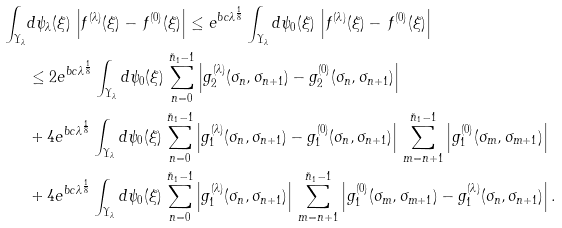Convert formula to latex. <formula><loc_0><loc_0><loc_500><loc_500>\int _ { \Upsilon _ { \lambda } } & d \psi _ { \lambda } ( \xi ) \, \left | f ^ { ( \lambda ) } ( \xi ) - \, f ^ { ( 0 ) } ( \xi ) \right | \leq e ^ { b c \lambda ^ { \frac { 1 } { 8 } } } \int _ { \Upsilon _ { \lambda } } d \psi _ { 0 } ( \xi ) \, \left | f ^ { ( \lambda ) } ( \xi ) - \, f ^ { ( 0 ) } ( \xi ) \right | \\ & \leq 2 e ^ { b c \lambda ^ { \frac { 1 } { 8 } } } \int _ { \Upsilon _ { \lambda } } d \psi _ { 0 } ( \xi ) \, \sum _ { n = 0 } ^ { \tilde { n } _ { 1 } - 1 } \left | g _ { 2 } ^ { ( \lambda ) } ( \sigma _ { n } , \sigma _ { n + 1 } ) - g _ { 2 } ^ { ( 0 ) } ( \sigma _ { n } , \sigma _ { n + 1 } ) \right | \\ & + 4 e ^ { b c \lambda ^ { \frac { 1 } { 8 } } } \int _ { \Upsilon _ { \lambda } } d \psi _ { 0 } ( \xi ) \, \sum _ { n = 0 } ^ { \tilde { n } _ { 1 } - 1 } \left | g _ { 1 } ^ { ( \lambda ) } ( \sigma _ { n } , \sigma _ { n + 1 } ) - g _ { 1 } ^ { ( 0 ) } ( \sigma _ { n } , \sigma _ { n + 1 } ) \right | \, \sum _ { m = n + 1 } ^ { \tilde { n } _ { 1 } - 1 } \left | g _ { 1 } ^ { ( 0 ) } ( \sigma _ { m } , \sigma _ { m + 1 } ) \right | \\ & + 4 e ^ { b c \lambda ^ { \frac { 1 } { 8 } } } \int _ { \Upsilon _ { \lambda } } d \psi _ { 0 } ( \xi ) \, \sum _ { n = 0 } ^ { \tilde { n } _ { 1 } - 1 } \left | g _ { 1 } ^ { ( \lambda ) } ( \sigma _ { n } , \sigma _ { n + 1 } ) \right | \, \sum _ { m = n + 1 } ^ { \tilde { n } _ { 1 } - 1 } \left | g _ { 1 } ^ { ( 0 ) } ( \sigma _ { m } , \sigma _ { m + 1 } ) - g _ { 1 } ^ { ( \lambda ) } ( \sigma _ { n } , \sigma _ { n + 1 } ) \right | .</formula> 